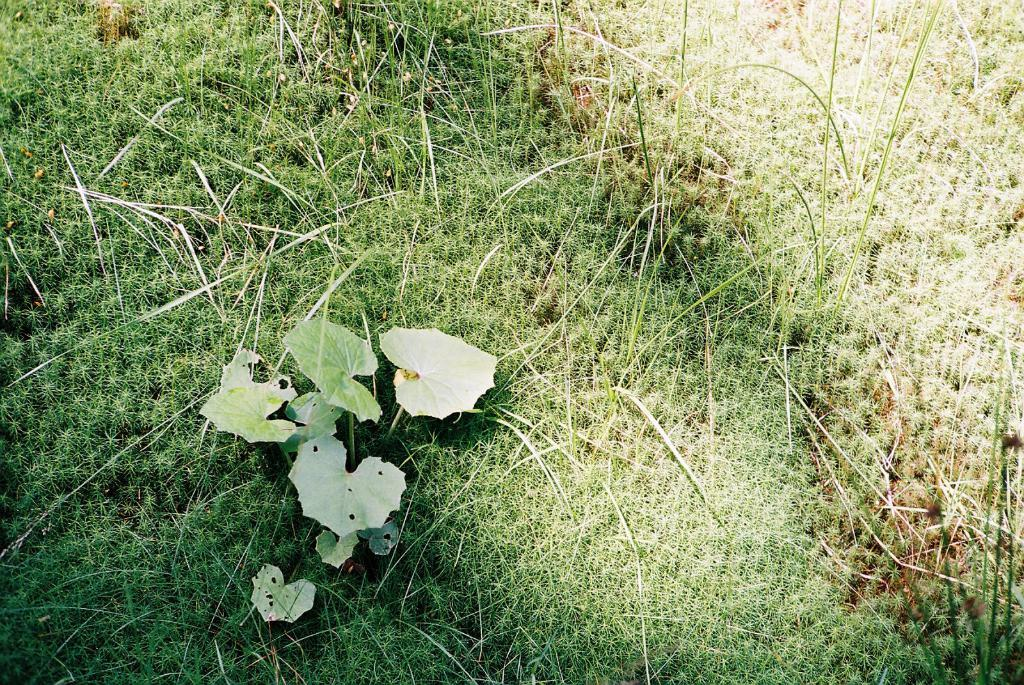What type of surface is visible in the image? There is a grass surface in the image. What is present on the grass surface? There is a plant with leaves on the grass surface. Can you describe the condition of the plant's leaves? The plant's leaves have holes in them. Where is the hen sitting on the grass surface in the image? There is no hen present in the image. What type of cup is being used to water the plant in the image? There is no cup visible in the image, and the plant's watering is not mentioned in the provided facts. 